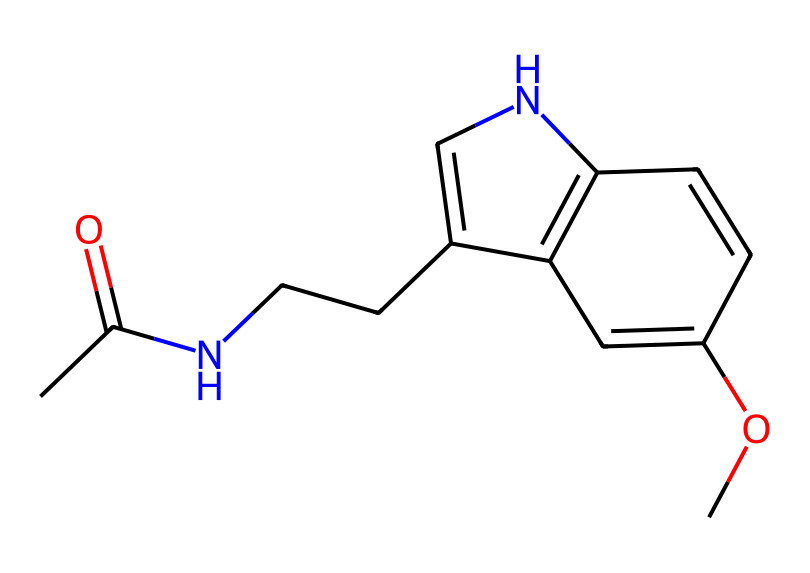What is the primary functional group in this molecule? The primary functional group in this molecule is the amide group, which is indicated by the carbonyl (C=O) bonded to a nitrogen atom (N).
Answer: amide How many carbon atoms are present in this molecule? By analyzing the SMILES notation, we can identify and count the carbon atoms represented. In this case, there are eight carbon atoms in the structure.
Answer: eight What is the effect of disturbed melatonin levels due to late-night binge-watching? Disturbed melatonin levels typically lead to sleep disruption, causing difficulties in falling and staying asleep.
Answer: sleep disruption Which element in this structure is associated with the molecule's role in regulating sleep? The nitrogen atom in this chemical structure is crucial for melatonin's role in regulating sleep since it's part of the amide group and affects receptor binding.
Answer: nitrogen What type of bonding is primarily present in melatonin? The bonding in melatonin is largely covalent, characterized by the sharing of electrons between atoms in this molecule.
Answer: covalent How many rings are present in the chemical structure of melatonin? The analysis shows that there is one ring structure within the molecule, specifically the pyridine ring incorporated in its structure.
Answer: one ring 